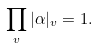<formula> <loc_0><loc_0><loc_500><loc_500>\prod _ { v } | \alpha | _ { v } = 1 .</formula> 